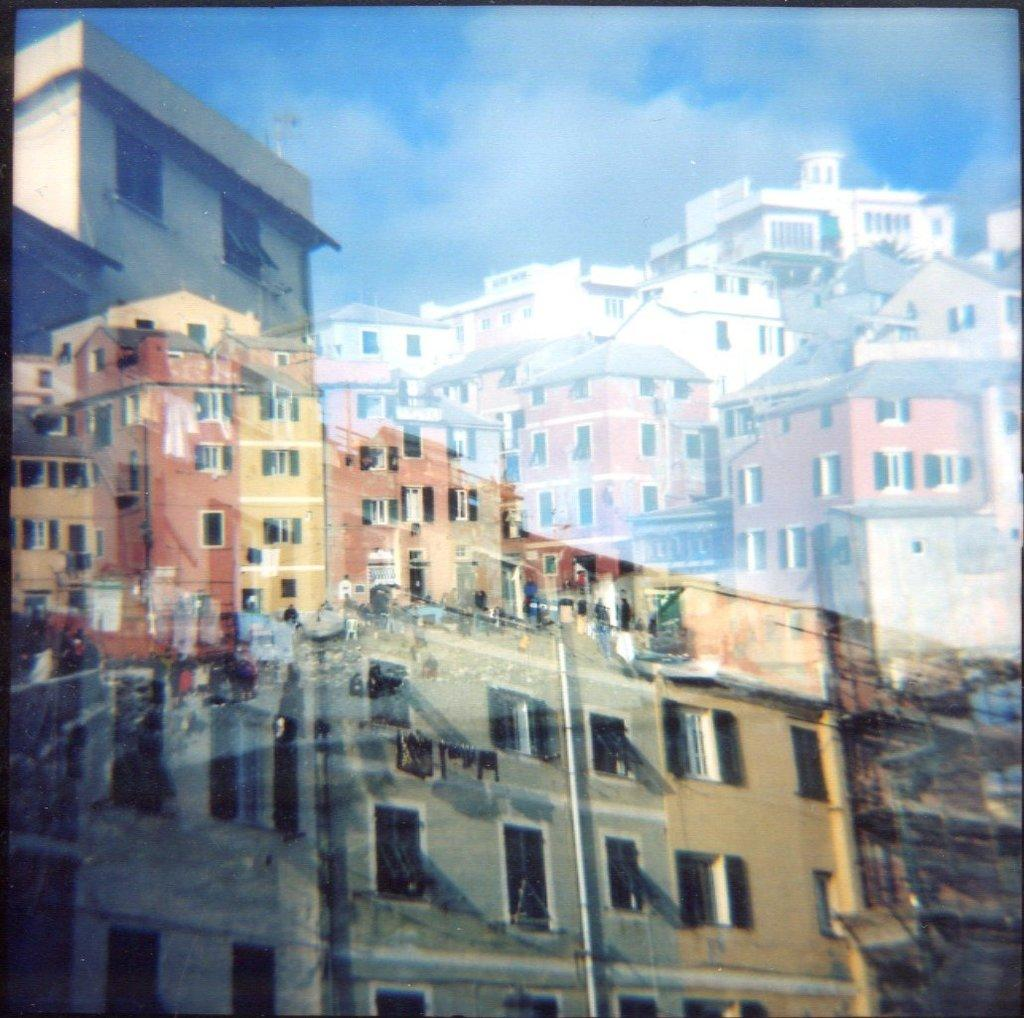What types of structures can be seen in the image? There are multiple buildings in the image. What architectural features can be observed on the buildings? Multiple windows are visible in the image. What is present in the sky in the image? There are clouds in the image. What else can be seen in the sky in the image? The sky is visible in the image. What type of poison is being used to water the flower in the image? There is no flower or poison present in the image. What is the yoke used for in the image? There is no yoke present in the image. 